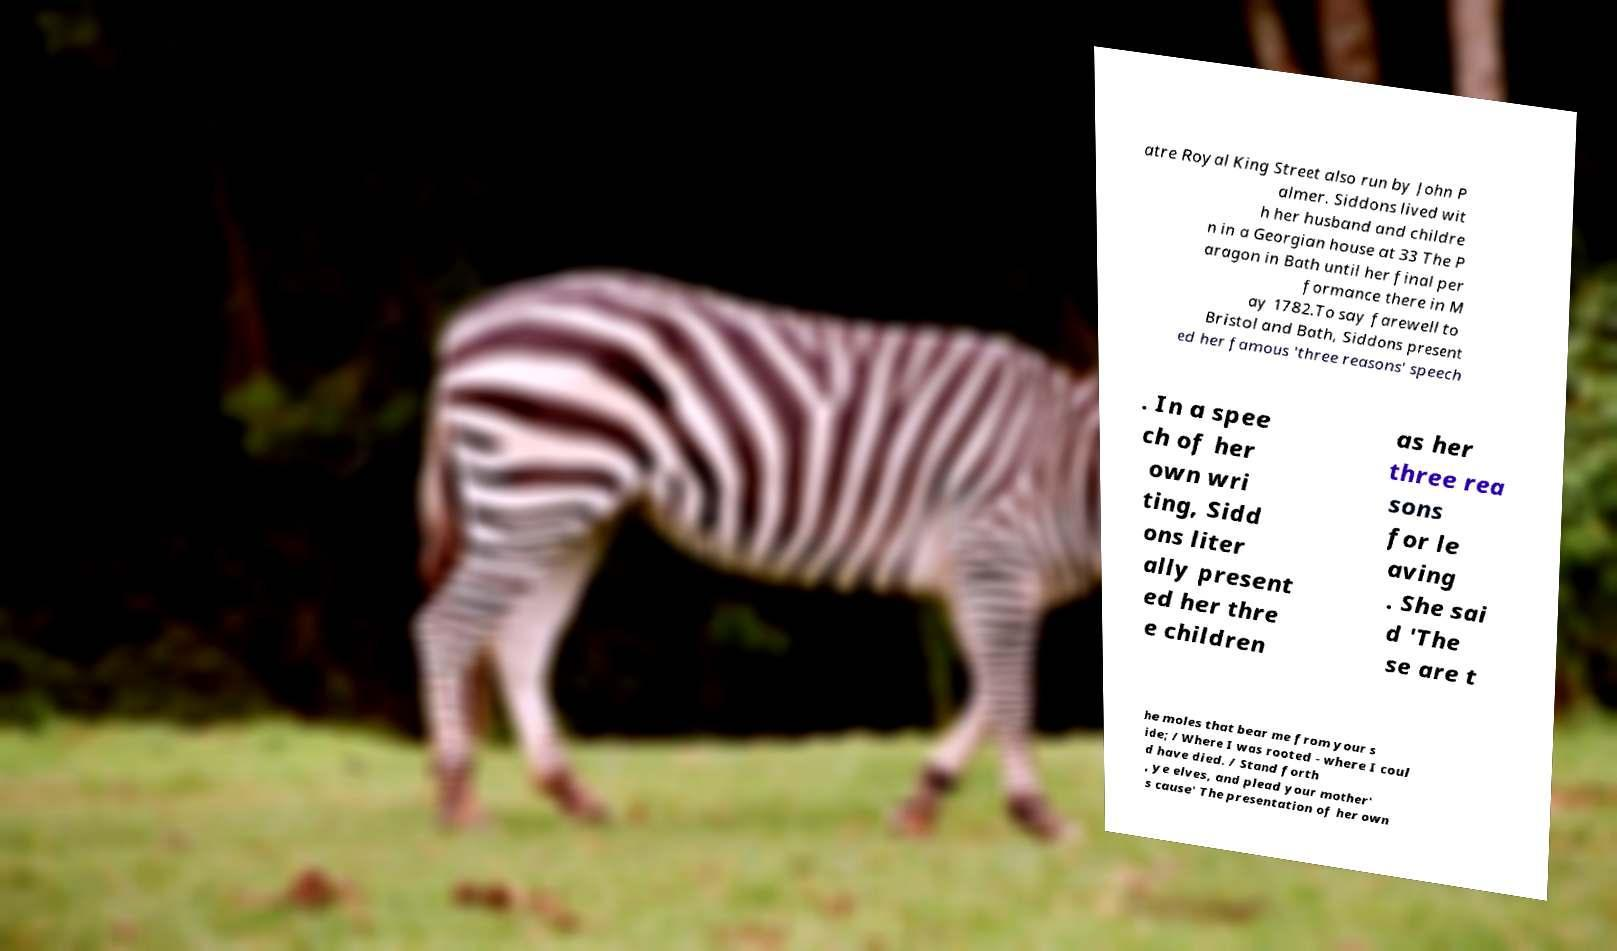Can you read and provide the text displayed in the image?This photo seems to have some interesting text. Can you extract and type it out for me? atre Royal King Street also run by John P almer. Siddons lived wit h her husband and childre n in a Georgian house at 33 The P aragon in Bath until her final per formance there in M ay 1782.To say farewell to Bristol and Bath, Siddons present ed her famous 'three reasons' speech . In a spee ch of her own wri ting, Sidd ons liter ally present ed her thre e children as her three rea sons for le aving . She sai d 'The se are t he moles that bear me from your s ide; / Where I was rooted - where I coul d have died. / Stand forth , ye elves, and plead your mother' s cause' The presentation of her own 